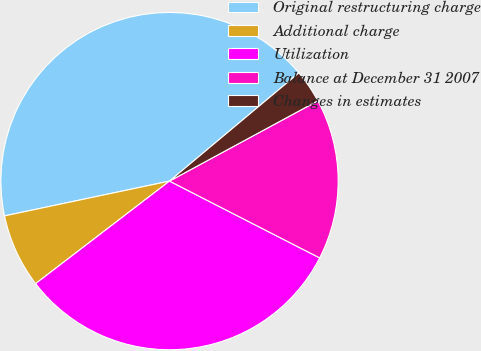Convert chart. <chart><loc_0><loc_0><loc_500><loc_500><pie_chart><fcel>Original restructuring charge<fcel>Additional charge<fcel>Utilization<fcel>Balance at December 31 2007<fcel>Changes in estimates<nl><fcel>42.22%<fcel>7.09%<fcel>32.07%<fcel>15.42%<fcel>3.19%<nl></chart> 